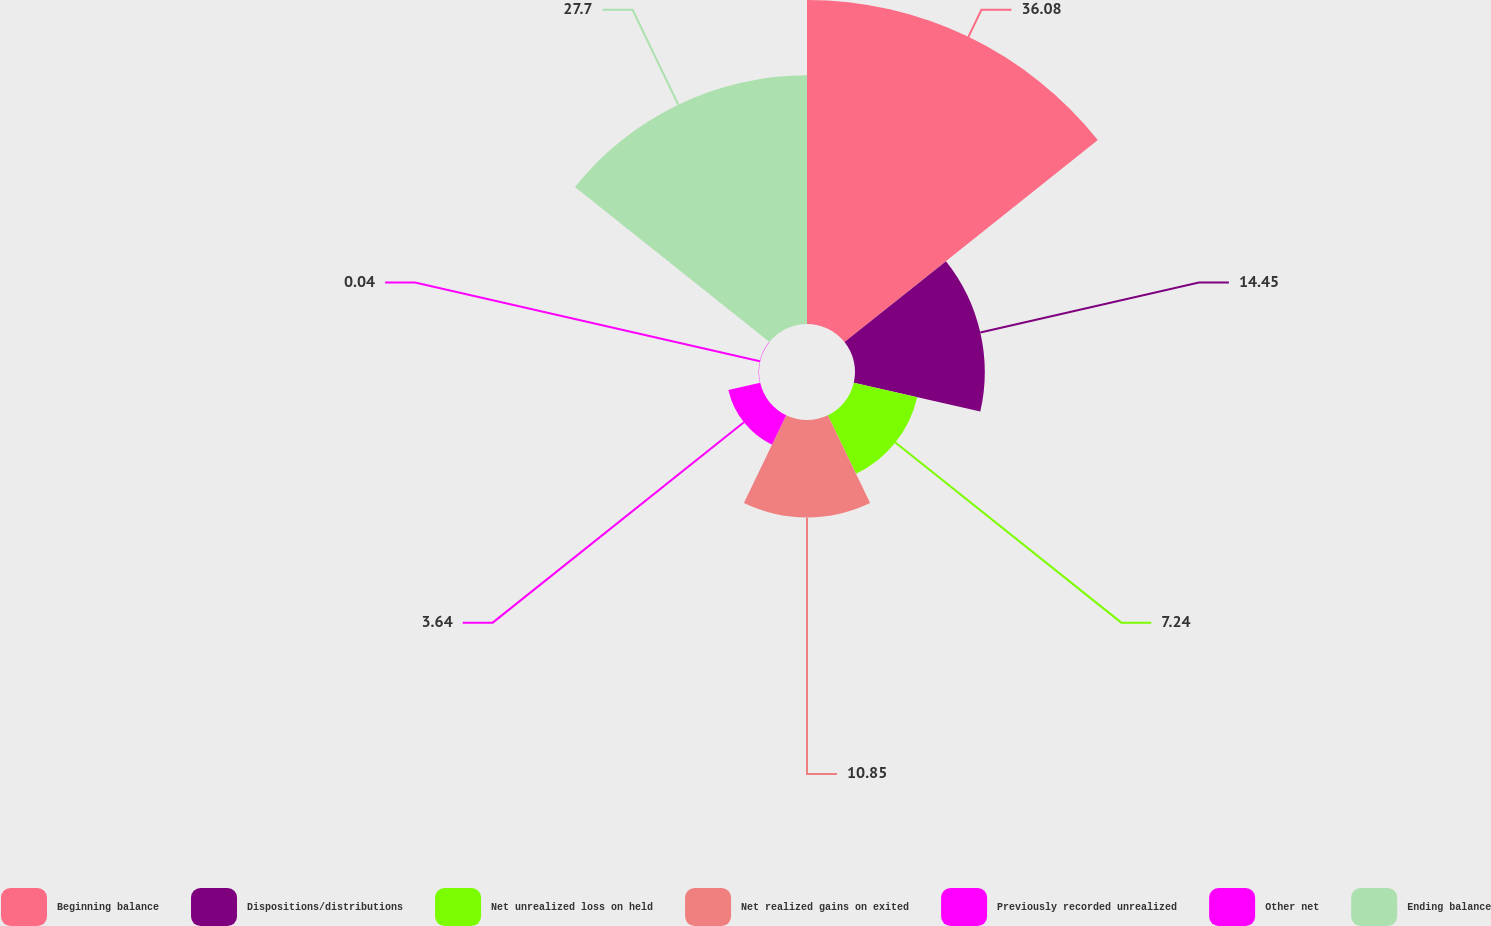<chart> <loc_0><loc_0><loc_500><loc_500><pie_chart><fcel>Beginning balance<fcel>Dispositions/distributions<fcel>Net unrealized loss on held<fcel>Net realized gains on exited<fcel>Previously recorded unrealized<fcel>Other net<fcel>Ending balance<nl><fcel>36.08%<fcel>14.45%<fcel>7.24%<fcel>10.85%<fcel>3.64%<fcel>0.04%<fcel>27.7%<nl></chart> 